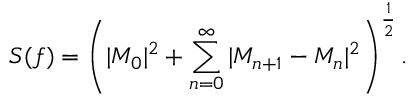<formula> <loc_0><loc_0><loc_500><loc_500>S ( f ) = \left ( | M _ { 0 } | ^ { 2 } + \sum _ { n = 0 } ^ { \infty } | M _ { n + 1 } - M _ { n } | ^ { 2 } \right ) ^ { \frac { 1 } { 2 } } .</formula> 